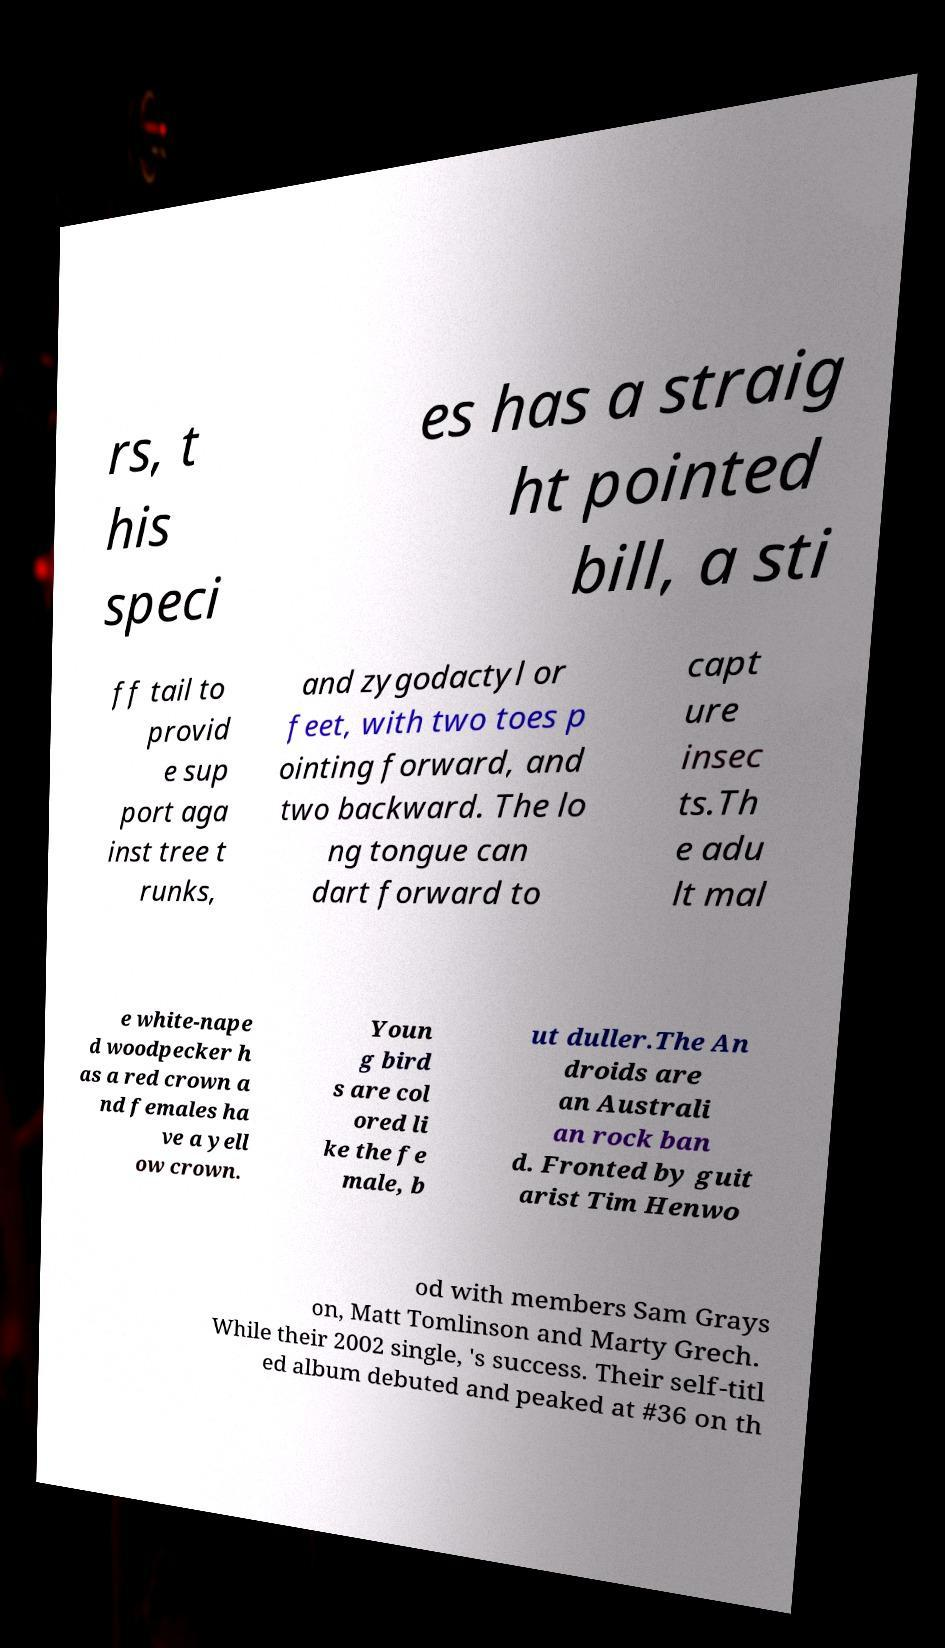Can you accurately transcribe the text from the provided image for me? rs, t his speci es has a straig ht pointed bill, a sti ff tail to provid e sup port aga inst tree t runks, and zygodactyl or feet, with two toes p ointing forward, and two backward. The lo ng tongue can dart forward to capt ure insec ts.Th e adu lt mal e white-nape d woodpecker h as a red crown a nd females ha ve a yell ow crown. Youn g bird s are col ored li ke the fe male, b ut duller.The An droids are an Australi an rock ban d. Fronted by guit arist Tim Henwo od with members Sam Grays on, Matt Tomlinson and Marty Grech. While their 2002 single, 's success. Their self-titl ed album debuted and peaked at #36 on th 